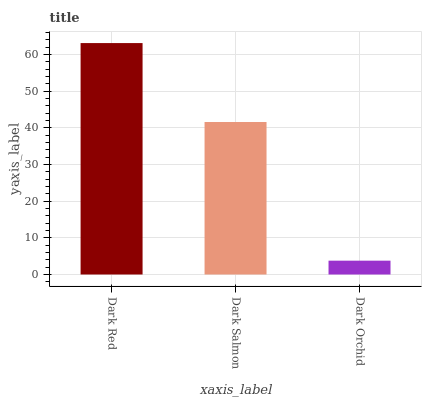Is Dark Orchid the minimum?
Answer yes or no. Yes. Is Dark Red the maximum?
Answer yes or no. Yes. Is Dark Salmon the minimum?
Answer yes or no. No. Is Dark Salmon the maximum?
Answer yes or no. No. Is Dark Red greater than Dark Salmon?
Answer yes or no. Yes. Is Dark Salmon less than Dark Red?
Answer yes or no. Yes. Is Dark Salmon greater than Dark Red?
Answer yes or no. No. Is Dark Red less than Dark Salmon?
Answer yes or no. No. Is Dark Salmon the high median?
Answer yes or no. Yes. Is Dark Salmon the low median?
Answer yes or no. Yes. Is Dark Orchid the high median?
Answer yes or no. No. Is Dark Red the low median?
Answer yes or no. No. 